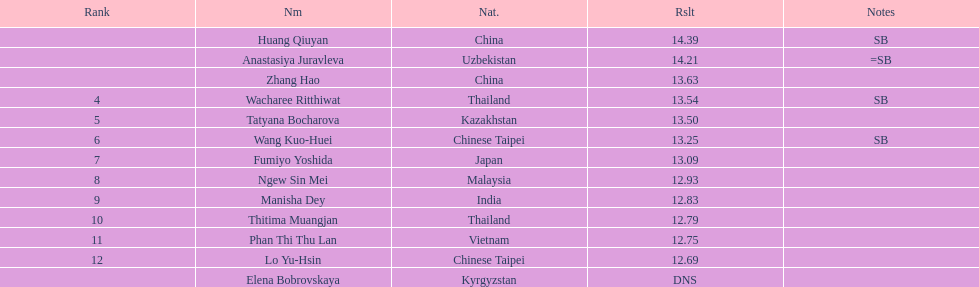How long was manisha dey's jump? 12.83. 